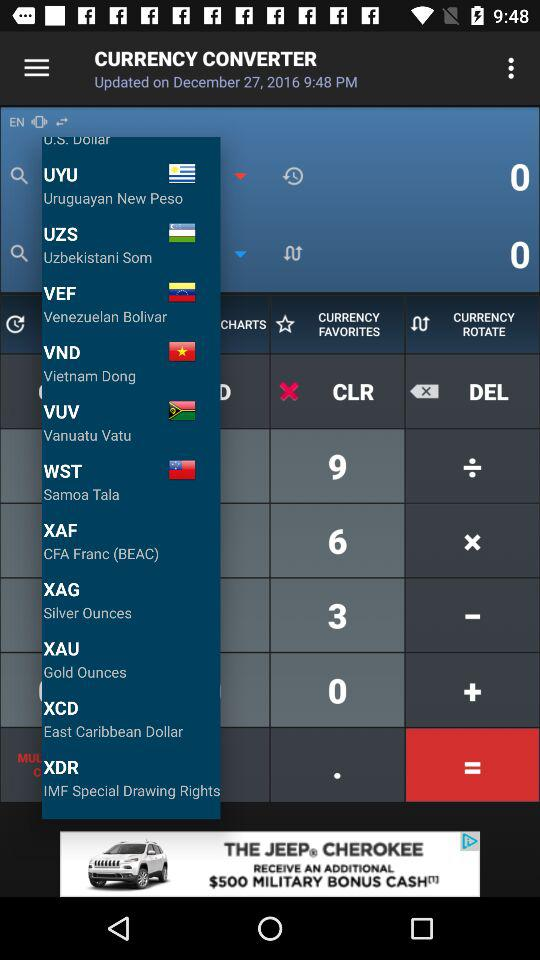What is the currency of Uruguay? The currency is the Uruguayan new peso. 